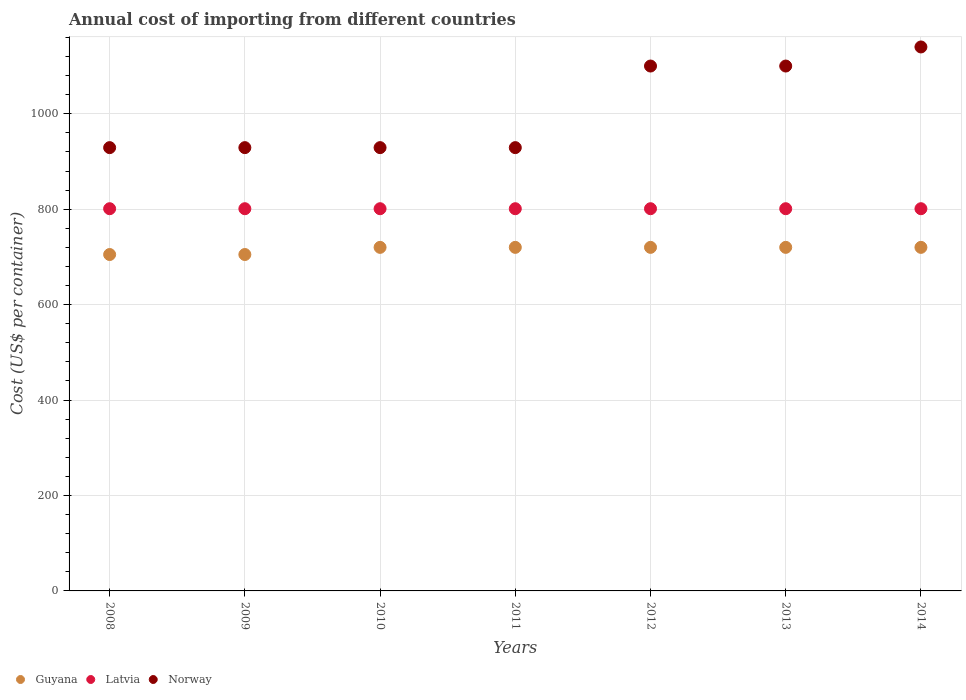Is the number of dotlines equal to the number of legend labels?
Your answer should be very brief. Yes. What is the total annual cost of importing in Norway in 2014?
Give a very brief answer. 1140. Across all years, what is the maximum total annual cost of importing in Norway?
Provide a succinct answer. 1140. Across all years, what is the minimum total annual cost of importing in Latvia?
Give a very brief answer. 801. In which year was the total annual cost of importing in Latvia maximum?
Provide a short and direct response. 2008. In which year was the total annual cost of importing in Latvia minimum?
Your answer should be very brief. 2008. What is the total total annual cost of importing in Latvia in the graph?
Provide a succinct answer. 5607. What is the difference between the total annual cost of importing in Latvia in 2012 and the total annual cost of importing in Norway in 2009?
Keep it short and to the point. -128. What is the average total annual cost of importing in Norway per year?
Provide a succinct answer. 1008. In the year 2011, what is the difference between the total annual cost of importing in Latvia and total annual cost of importing in Norway?
Your answer should be very brief. -128. In how many years, is the total annual cost of importing in Guyana greater than 880 US$?
Provide a short and direct response. 0. What is the ratio of the total annual cost of importing in Latvia in 2008 to that in 2009?
Offer a very short reply. 1. Is the total annual cost of importing in Norway in 2009 less than that in 2012?
Make the answer very short. Yes. Is the difference between the total annual cost of importing in Latvia in 2010 and 2013 greater than the difference between the total annual cost of importing in Norway in 2010 and 2013?
Provide a short and direct response. Yes. What is the difference between the highest and the second highest total annual cost of importing in Norway?
Make the answer very short. 40. What is the difference between the highest and the lowest total annual cost of importing in Norway?
Keep it short and to the point. 211. Is it the case that in every year, the sum of the total annual cost of importing in Guyana and total annual cost of importing in Norway  is greater than the total annual cost of importing in Latvia?
Make the answer very short. Yes. Is the total annual cost of importing in Latvia strictly greater than the total annual cost of importing in Norway over the years?
Offer a very short reply. No. Is the total annual cost of importing in Latvia strictly less than the total annual cost of importing in Guyana over the years?
Your answer should be very brief. No. How many dotlines are there?
Give a very brief answer. 3. How many years are there in the graph?
Your response must be concise. 7. Does the graph contain grids?
Ensure brevity in your answer.  Yes. How are the legend labels stacked?
Provide a succinct answer. Horizontal. What is the title of the graph?
Offer a very short reply. Annual cost of importing from different countries. What is the label or title of the X-axis?
Provide a succinct answer. Years. What is the label or title of the Y-axis?
Offer a terse response. Cost (US$ per container). What is the Cost (US$ per container) of Guyana in 2008?
Your answer should be compact. 705. What is the Cost (US$ per container) of Latvia in 2008?
Give a very brief answer. 801. What is the Cost (US$ per container) of Norway in 2008?
Offer a terse response. 929. What is the Cost (US$ per container) of Guyana in 2009?
Keep it short and to the point. 705. What is the Cost (US$ per container) of Latvia in 2009?
Offer a terse response. 801. What is the Cost (US$ per container) of Norway in 2009?
Make the answer very short. 929. What is the Cost (US$ per container) of Guyana in 2010?
Ensure brevity in your answer.  720. What is the Cost (US$ per container) of Latvia in 2010?
Provide a short and direct response. 801. What is the Cost (US$ per container) in Norway in 2010?
Your answer should be very brief. 929. What is the Cost (US$ per container) of Guyana in 2011?
Ensure brevity in your answer.  720. What is the Cost (US$ per container) of Latvia in 2011?
Your answer should be very brief. 801. What is the Cost (US$ per container) of Norway in 2011?
Your response must be concise. 929. What is the Cost (US$ per container) of Guyana in 2012?
Make the answer very short. 720. What is the Cost (US$ per container) of Latvia in 2012?
Your answer should be very brief. 801. What is the Cost (US$ per container) in Norway in 2012?
Ensure brevity in your answer.  1100. What is the Cost (US$ per container) in Guyana in 2013?
Provide a succinct answer. 720. What is the Cost (US$ per container) of Latvia in 2013?
Make the answer very short. 801. What is the Cost (US$ per container) of Norway in 2013?
Make the answer very short. 1100. What is the Cost (US$ per container) in Guyana in 2014?
Provide a short and direct response. 720. What is the Cost (US$ per container) of Latvia in 2014?
Keep it short and to the point. 801. What is the Cost (US$ per container) of Norway in 2014?
Ensure brevity in your answer.  1140. Across all years, what is the maximum Cost (US$ per container) of Guyana?
Ensure brevity in your answer.  720. Across all years, what is the maximum Cost (US$ per container) in Latvia?
Keep it short and to the point. 801. Across all years, what is the maximum Cost (US$ per container) in Norway?
Your answer should be very brief. 1140. Across all years, what is the minimum Cost (US$ per container) of Guyana?
Provide a short and direct response. 705. Across all years, what is the minimum Cost (US$ per container) of Latvia?
Provide a succinct answer. 801. Across all years, what is the minimum Cost (US$ per container) in Norway?
Offer a terse response. 929. What is the total Cost (US$ per container) in Guyana in the graph?
Provide a short and direct response. 5010. What is the total Cost (US$ per container) in Latvia in the graph?
Ensure brevity in your answer.  5607. What is the total Cost (US$ per container) in Norway in the graph?
Provide a succinct answer. 7056. What is the difference between the Cost (US$ per container) in Norway in 2008 and that in 2009?
Your answer should be compact. 0. What is the difference between the Cost (US$ per container) of Norway in 2008 and that in 2010?
Your answer should be compact. 0. What is the difference between the Cost (US$ per container) of Guyana in 2008 and that in 2011?
Make the answer very short. -15. What is the difference between the Cost (US$ per container) in Norway in 2008 and that in 2011?
Your response must be concise. 0. What is the difference between the Cost (US$ per container) in Norway in 2008 and that in 2012?
Provide a short and direct response. -171. What is the difference between the Cost (US$ per container) of Norway in 2008 and that in 2013?
Your response must be concise. -171. What is the difference between the Cost (US$ per container) of Latvia in 2008 and that in 2014?
Provide a short and direct response. 0. What is the difference between the Cost (US$ per container) of Norway in 2008 and that in 2014?
Your response must be concise. -211. What is the difference between the Cost (US$ per container) of Guyana in 2009 and that in 2010?
Offer a very short reply. -15. What is the difference between the Cost (US$ per container) in Latvia in 2009 and that in 2010?
Provide a short and direct response. 0. What is the difference between the Cost (US$ per container) of Latvia in 2009 and that in 2011?
Keep it short and to the point. 0. What is the difference between the Cost (US$ per container) in Norway in 2009 and that in 2011?
Make the answer very short. 0. What is the difference between the Cost (US$ per container) of Guyana in 2009 and that in 2012?
Keep it short and to the point. -15. What is the difference between the Cost (US$ per container) of Norway in 2009 and that in 2012?
Your response must be concise. -171. What is the difference between the Cost (US$ per container) in Latvia in 2009 and that in 2013?
Offer a terse response. 0. What is the difference between the Cost (US$ per container) of Norway in 2009 and that in 2013?
Your answer should be very brief. -171. What is the difference between the Cost (US$ per container) of Guyana in 2009 and that in 2014?
Provide a succinct answer. -15. What is the difference between the Cost (US$ per container) of Norway in 2009 and that in 2014?
Offer a very short reply. -211. What is the difference between the Cost (US$ per container) of Guyana in 2010 and that in 2012?
Give a very brief answer. 0. What is the difference between the Cost (US$ per container) in Norway in 2010 and that in 2012?
Offer a very short reply. -171. What is the difference between the Cost (US$ per container) in Guyana in 2010 and that in 2013?
Keep it short and to the point. 0. What is the difference between the Cost (US$ per container) in Latvia in 2010 and that in 2013?
Keep it short and to the point. 0. What is the difference between the Cost (US$ per container) in Norway in 2010 and that in 2013?
Offer a very short reply. -171. What is the difference between the Cost (US$ per container) of Guyana in 2010 and that in 2014?
Make the answer very short. 0. What is the difference between the Cost (US$ per container) of Norway in 2010 and that in 2014?
Your response must be concise. -211. What is the difference between the Cost (US$ per container) in Guyana in 2011 and that in 2012?
Keep it short and to the point. 0. What is the difference between the Cost (US$ per container) in Latvia in 2011 and that in 2012?
Offer a very short reply. 0. What is the difference between the Cost (US$ per container) in Norway in 2011 and that in 2012?
Provide a succinct answer. -171. What is the difference between the Cost (US$ per container) of Guyana in 2011 and that in 2013?
Provide a short and direct response. 0. What is the difference between the Cost (US$ per container) in Latvia in 2011 and that in 2013?
Provide a succinct answer. 0. What is the difference between the Cost (US$ per container) in Norway in 2011 and that in 2013?
Offer a very short reply. -171. What is the difference between the Cost (US$ per container) of Guyana in 2011 and that in 2014?
Provide a succinct answer. 0. What is the difference between the Cost (US$ per container) of Norway in 2011 and that in 2014?
Provide a short and direct response. -211. What is the difference between the Cost (US$ per container) of Latvia in 2012 and that in 2013?
Ensure brevity in your answer.  0. What is the difference between the Cost (US$ per container) in Guyana in 2013 and that in 2014?
Ensure brevity in your answer.  0. What is the difference between the Cost (US$ per container) of Norway in 2013 and that in 2014?
Provide a short and direct response. -40. What is the difference between the Cost (US$ per container) in Guyana in 2008 and the Cost (US$ per container) in Latvia in 2009?
Your response must be concise. -96. What is the difference between the Cost (US$ per container) of Guyana in 2008 and the Cost (US$ per container) of Norway in 2009?
Keep it short and to the point. -224. What is the difference between the Cost (US$ per container) of Latvia in 2008 and the Cost (US$ per container) of Norway in 2009?
Provide a succinct answer. -128. What is the difference between the Cost (US$ per container) of Guyana in 2008 and the Cost (US$ per container) of Latvia in 2010?
Your answer should be very brief. -96. What is the difference between the Cost (US$ per container) in Guyana in 2008 and the Cost (US$ per container) in Norway in 2010?
Your response must be concise. -224. What is the difference between the Cost (US$ per container) of Latvia in 2008 and the Cost (US$ per container) of Norway in 2010?
Ensure brevity in your answer.  -128. What is the difference between the Cost (US$ per container) of Guyana in 2008 and the Cost (US$ per container) of Latvia in 2011?
Offer a very short reply. -96. What is the difference between the Cost (US$ per container) of Guyana in 2008 and the Cost (US$ per container) of Norway in 2011?
Give a very brief answer. -224. What is the difference between the Cost (US$ per container) of Latvia in 2008 and the Cost (US$ per container) of Norway in 2011?
Your answer should be compact. -128. What is the difference between the Cost (US$ per container) in Guyana in 2008 and the Cost (US$ per container) in Latvia in 2012?
Offer a very short reply. -96. What is the difference between the Cost (US$ per container) of Guyana in 2008 and the Cost (US$ per container) of Norway in 2012?
Your answer should be very brief. -395. What is the difference between the Cost (US$ per container) of Latvia in 2008 and the Cost (US$ per container) of Norway in 2012?
Offer a terse response. -299. What is the difference between the Cost (US$ per container) in Guyana in 2008 and the Cost (US$ per container) in Latvia in 2013?
Give a very brief answer. -96. What is the difference between the Cost (US$ per container) in Guyana in 2008 and the Cost (US$ per container) in Norway in 2013?
Ensure brevity in your answer.  -395. What is the difference between the Cost (US$ per container) in Latvia in 2008 and the Cost (US$ per container) in Norway in 2013?
Keep it short and to the point. -299. What is the difference between the Cost (US$ per container) of Guyana in 2008 and the Cost (US$ per container) of Latvia in 2014?
Give a very brief answer. -96. What is the difference between the Cost (US$ per container) in Guyana in 2008 and the Cost (US$ per container) in Norway in 2014?
Give a very brief answer. -435. What is the difference between the Cost (US$ per container) of Latvia in 2008 and the Cost (US$ per container) of Norway in 2014?
Make the answer very short. -339. What is the difference between the Cost (US$ per container) of Guyana in 2009 and the Cost (US$ per container) of Latvia in 2010?
Give a very brief answer. -96. What is the difference between the Cost (US$ per container) of Guyana in 2009 and the Cost (US$ per container) of Norway in 2010?
Your response must be concise. -224. What is the difference between the Cost (US$ per container) in Latvia in 2009 and the Cost (US$ per container) in Norway in 2010?
Offer a very short reply. -128. What is the difference between the Cost (US$ per container) in Guyana in 2009 and the Cost (US$ per container) in Latvia in 2011?
Provide a short and direct response. -96. What is the difference between the Cost (US$ per container) in Guyana in 2009 and the Cost (US$ per container) in Norway in 2011?
Keep it short and to the point. -224. What is the difference between the Cost (US$ per container) of Latvia in 2009 and the Cost (US$ per container) of Norway in 2011?
Make the answer very short. -128. What is the difference between the Cost (US$ per container) of Guyana in 2009 and the Cost (US$ per container) of Latvia in 2012?
Make the answer very short. -96. What is the difference between the Cost (US$ per container) of Guyana in 2009 and the Cost (US$ per container) of Norway in 2012?
Your response must be concise. -395. What is the difference between the Cost (US$ per container) of Latvia in 2009 and the Cost (US$ per container) of Norway in 2012?
Provide a succinct answer. -299. What is the difference between the Cost (US$ per container) of Guyana in 2009 and the Cost (US$ per container) of Latvia in 2013?
Your response must be concise. -96. What is the difference between the Cost (US$ per container) in Guyana in 2009 and the Cost (US$ per container) in Norway in 2013?
Give a very brief answer. -395. What is the difference between the Cost (US$ per container) in Latvia in 2009 and the Cost (US$ per container) in Norway in 2013?
Your response must be concise. -299. What is the difference between the Cost (US$ per container) of Guyana in 2009 and the Cost (US$ per container) of Latvia in 2014?
Ensure brevity in your answer.  -96. What is the difference between the Cost (US$ per container) of Guyana in 2009 and the Cost (US$ per container) of Norway in 2014?
Your response must be concise. -435. What is the difference between the Cost (US$ per container) of Latvia in 2009 and the Cost (US$ per container) of Norway in 2014?
Provide a short and direct response. -339. What is the difference between the Cost (US$ per container) in Guyana in 2010 and the Cost (US$ per container) in Latvia in 2011?
Your answer should be compact. -81. What is the difference between the Cost (US$ per container) of Guyana in 2010 and the Cost (US$ per container) of Norway in 2011?
Offer a very short reply. -209. What is the difference between the Cost (US$ per container) in Latvia in 2010 and the Cost (US$ per container) in Norway in 2011?
Keep it short and to the point. -128. What is the difference between the Cost (US$ per container) of Guyana in 2010 and the Cost (US$ per container) of Latvia in 2012?
Your answer should be compact. -81. What is the difference between the Cost (US$ per container) of Guyana in 2010 and the Cost (US$ per container) of Norway in 2012?
Provide a succinct answer. -380. What is the difference between the Cost (US$ per container) of Latvia in 2010 and the Cost (US$ per container) of Norway in 2012?
Keep it short and to the point. -299. What is the difference between the Cost (US$ per container) in Guyana in 2010 and the Cost (US$ per container) in Latvia in 2013?
Ensure brevity in your answer.  -81. What is the difference between the Cost (US$ per container) in Guyana in 2010 and the Cost (US$ per container) in Norway in 2013?
Provide a succinct answer. -380. What is the difference between the Cost (US$ per container) in Latvia in 2010 and the Cost (US$ per container) in Norway in 2013?
Offer a terse response. -299. What is the difference between the Cost (US$ per container) in Guyana in 2010 and the Cost (US$ per container) in Latvia in 2014?
Offer a terse response. -81. What is the difference between the Cost (US$ per container) of Guyana in 2010 and the Cost (US$ per container) of Norway in 2014?
Offer a terse response. -420. What is the difference between the Cost (US$ per container) in Latvia in 2010 and the Cost (US$ per container) in Norway in 2014?
Offer a terse response. -339. What is the difference between the Cost (US$ per container) of Guyana in 2011 and the Cost (US$ per container) of Latvia in 2012?
Ensure brevity in your answer.  -81. What is the difference between the Cost (US$ per container) of Guyana in 2011 and the Cost (US$ per container) of Norway in 2012?
Give a very brief answer. -380. What is the difference between the Cost (US$ per container) in Latvia in 2011 and the Cost (US$ per container) in Norway in 2012?
Your response must be concise. -299. What is the difference between the Cost (US$ per container) of Guyana in 2011 and the Cost (US$ per container) of Latvia in 2013?
Ensure brevity in your answer.  -81. What is the difference between the Cost (US$ per container) of Guyana in 2011 and the Cost (US$ per container) of Norway in 2013?
Your response must be concise. -380. What is the difference between the Cost (US$ per container) in Latvia in 2011 and the Cost (US$ per container) in Norway in 2013?
Ensure brevity in your answer.  -299. What is the difference between the Cost (US$ per container) in Guyana in 2011 and the Cost (US$ per container) in Latvia in 2014?
Offer a very short reply. -81. What is the difference between the Cost (US$ per container) of Guyana in 2011 and the Cost (US$ per container) of Norway in 2014?
Provide a short and direct response. -420. What is the difference between the Cost (US$ per container) of Latvia in 2011 and the Cost (US$ per container) of Norway in 2014?
Provide a short and direct response. -339. What is the difference between the Cost (US$ per container) in Guyana in 2012 and the Cost (US$ per container) in Latvia in 2013?
Give a very brief answer. -81. What is the difference between the Cost (US$ per container) of Guyana in 2012 and the Cost (US$ per container) of Norway in 2013?
Offer a terse response. -380. What is the difference between the Cost (US$ per container) in Latvia in 2012 and the Cost (US$ per container) in Norway in 2013?
Provide a short and direct response. -299. What is the difference between the Cost (US$ per container) of Guyana in 2012 and the Cost (US$ per container) of Latvia in 2014?
Your answer should be compact. -81. What is the difference between the Cost (US$ per container) in Guyana in 2012 and the Cost (US$ per container) in Norway in 2014?
Ensure brevity in your answer.  -420. What is the difference between the Cost (US$ per container) in Latvia in 2012 and the Cost (US$ per container) in Norway in 2014?
Your answer should be compact. -339. What is the difference between the Cost (US$ per container) in Guyana in 2013 and the Cost (US$ per container) in Latvia in 2014?
Your response must be concise. -81. What is the difference between the Cost (US$ per container) in Guyana in 2013 and the Cost (US$ per container) in Norway in 2014?
Your answer should be very brief. -420. What is the difference between the Cost (US$ per container) in Latvia in 2013 and the Cost (US$ per container) in Norway in 2014?
Your answer should be very brief. -339. What is the average Cost (US$ per container) in Guyana per year?
Make the answer very short. 715.71. What is the average Cost (US$ per container) of Latvia per year?
Keep it short and to the point. 801. What is the average Cost (US$ per container) of Norway per year?
Offer a terse response. 1008. In the year 2008, what is the difference between the Cost (US$ per container) of Guyana and Cost (US$ per container) of Latvia?
Your answer should be very brief. -96. In the year 2008, what is the difference between the Cost (US$ per container) in Guyana and Cost (US$ per container) in Norway?
Ensure brevity in your answer.  -224. In the year 2008, what is the difference between the Cost (US$ per container) in Latvia and Cost (US$ per container) in Norway?
Keep it short and to the point. -128. In the year 2009, what is the difference between the Cost (US$ per container) in Guyana and Cost (US$ per container) in Latvia?
Your response must be concise. -96. In the year 2009, what is the difference between the Cost (US$ per container) of Guyana and Cost (US$ per container) of Norway?
Your answer should be very brief. -224. In the year 2009, what is the difference between the Cost (US$ per container) in Latvia and Cost (US$ per container) in Norway?
Your answer should be compact. -128. In the year 2010, what is the difference between the Cost (US$ per container) in Guyana and Cost (US$ per container) in Latvia?
Provide a short and direct response. -81. In the year 2010, what is the difference between the Cost (US$ per container) in Guyana and Cost (US$ per container) in Norway?
Offer a very short reply. -209. In the year 2010, what is the difference between the Cost (US$ per container) of Latvia and Cost (US$ per container) of Norway?
Give a very brief answer. -128. In the year 2011, what is the difference between the Cost (US$ per container) in Guyana and Cost (US$ per container) in Latvia?
Your answer should be very brief. -81. In the year 2011, what is the difference between the Cost (US$ per container) in Guyana and Cost (US$ per container) in Norway?
Your answer should be very brief. -209. In the year 2011, what is the difference between the Cost (US$ per container) of Latvia and Cost (US$ per container) of Norway?
Your answer should be very brief. -128. In the year 2012, what is the difference between the Cost (US$ per container) of Guyana and Cost (US$ per container) of Latvia?
Offer a very short reply. -81. In the year 2012, what is the difference between the Cost (US$ per container) of Guyana and Cost (US$ per container) of Norway?
Your answer should be very brief. -380. In the year 2012, what is the difference between the Cost (US$ per container) in Latvia and Cost (US$ per container) in Norway?
Ensure brevity in your answer.  -299. In the year 2013, what is the difference between the Cost (US$ per container) in Guyana and Cost (US$ per container) in Latvia?
Your answer should be very brief. -81. In the year 2013, what is the difference between the Cost (US$ per container) in Guyana and Cost (US$ per container) in Norway?
Provide a short and direct response. -380. In the year 2013, what is the difference between the Cost (US$ per container) of Latvia and Cost (US$ per container) of Norway?
Give a very brief answer. -299. In the year 2014, what is the difference between the Cost (US$ per container) in Guyana and Cost (US$ per container) in Latvia?
Provide a short and direct response. -81. In the year 2014, what is the difference between the Cost (US$ per container) of Guyana and Cost (US$ per container) of Norway?
Your answer should be very brief. -420. In the year 2014, what is the difference between the Cost (US$ per container) in Latvia and Cost (US$ per container) in Norway?
Provide a short and direct response. -339. What is the ratio of the Cost (US$ per container) of Guyana in 2008 to that in 2009?
Provide a succinct answer. 1. What is the ratio of the Cost (US$ per container) of Latvia in 2008 to that in 2009?
Your response must be concise. 1. What is the ratio of the Cost (US$ per container) of Norway in 2008 to that in 2009?
Provide a short and direct response. 1. What is the ratio of the Cost (US$ per container) of Guyana in 2008 to that in 2010?
Your answer should be compact. 0.98. What is the ratio of the Cost (US$ per container) of Latvia in 2008 to that in 2010?
Your response must be concise. 1. What is the ratio of the Cost (US$ per container) in Guyana in 2008 to that in 2011?
Make the answer very short. 0.98. What is the ratio of the Cost (US$ per container) of Latvia in 2008 to that in 2011?
Ensure brevity in your answer.  1. What is the ratio of the Cost (US$ per container) of Norway in 2008 to that in 2011?
Provide a short and direct response. 1. What is the ratio of the Cost (US$ per container) of Guyana in 2008 to that in 2012?
Give a very brief answer. 0.98. What is the ratio of the Cost (US$ per container) of Norway in 2008 to that in 2012?
Your answer should be very brief. 0.84. What is the ratio of the Cost (US$ per container) of Guyana in 2008 to that in 2013?
Ensure brevity in your answer.  0.98. What is the ratio of the Cost (US$ per container) of Latvia in 2008 to that in 2013?
Your response must be concise. 1. What is the ratio of the Cost (US$ per container) in Norway in 2008 to that in 2013?
Offer a terse response. 0.84. What is the ratio of the Cost (US$ per container) in Guyana in 2008 to that in 2014?
Offer a very short reply. 0.98. What is the ratio of the Cost (US$ per container) of Latvia in 2008 to that in 2014?
Offer a very short reply. 1. What is the ratio of the Cost (US$ per container) in Norway in 2008 to that in 2014?
Keep it short and to the point. 0.81. What is the ratio of the Cost (US$ per container) in Guyana in 2009 to that in 2010?
Ensure brevity in your answer.  0.98. What is the ratio of the Cost (US$ per container) of Guyana in 2009 to that in 2011?
Your answer should be very brief. 0.98. What is the ratio of the Cost (US$ per container) of Norway in 2009 to that in 2011?
Provide a short and direct response. 1. What is the ratio of the Cost (US$ per container) of Guyana in 2009 to that in 2012?
Provide a succinct answer. 0.98. What is the ratio of the Cost (US$ per container) of Norway in 2009 to that in 2012?
Give a very brief answer. 0.84. What is the ratio of the Cost (US$ per container) in Guyana in 2009 to that in 2013?
Give a very brief answer. 0.98. What is the ratio of the Cost (US$ per container) of Latvia in 2009 to that in 2013?
Ensure brevity in your answer.  1. What is the ratio of the Cost (US$ per container) in Norway in 2009 to that in 2013?
Provide a short and direct response. 0.84. What is the ratio of the Cost (US$ per container) of Guyana in 2009 to that in 2014?
Give a very brief answer. 0.98. What is the ratio of the Cost (US$ per container) in Latvia in 2009 to that in 2014?
Offer a very short reply. 1. What is the ratio of the Cost (US$ per container) in Norway in 2009 to that in 2014?
Your response must be concise. 0.81. What is the ratio of the Cost (US$ per container) of Guyana in 2010 to that in 2011?
Provide a succinct answer. 1. What is the ratio of the Cost (US$ per container) in Norway in 2010 to that in 2011?
Offer a very short reply. 1. What is the ratio of the Cost (US$ per container) of Norway in 2010 to that in 2012?
Keep it short and to the point. 0.84. What is the ratio of the Cost (US$ per container) in Guyana in 2010 to that in 2013?
Offer a very short reply. 1. What is the ratio of the Cost (US$ per container) in Norway in 2010 to that in 2013?
Provide a succinct answer. 0.84. What is the ratio of the Cost (US$ per container) in Guyana in 2010 to that in 2014?
Ensure brevity in your answer.  1. What is the ratio of the Cost (US$ per container) in Norway in 2010 to that in 2014?
Give a very brief answer. 0.81. What is the ratio of the Cost (US$ per container) in Guyana in 2011 to that in 2012?
Offer a terse response. 1. What is the ratio of the Cost (US$ per container) in Norway in 2011 to that in 2012?
Provide a short and direct response. 0.84. What is the ratio of the Cost (US$ per container) in Norway in 2011 to that in 2013?
Offer a terse response. 0.84. What is the ratio of the Cost (US$ per container) in Norway in 2011 to that in 2014?
Give a very brief answer. 0.81. What is the ratio of the Cost (US$ per container) of Norway in 2012 to that in 2013?
Keep it short and to the point. 1. What is the ratio of the Cost (US$ per container) in Guyana in 2012 to that in 2014?
Offer a very short reply. 1. What is the ratio of the Cost (US$ per container) in Latvia in 2012 to that in 2014?
Make the answer very short. 1. What is the ratio of the Cost (US$ per container) in Norway in 2012 to that in 2014?
Ensure brevity in your answer.  0.96. What is the ratio of the Cost (US$ per container) in Guyana in 2013 to that in 2014?
Your answer should be compact. 1. What is the ratio of the Cost (US$ per container) in Norway in 2013 to that in 2014?
Keep it short and to the point. 0.96. What is the difference between the highest and the second highest Cost (US$ per container) of Guyana?
Your answer should be very brief. 0. What is the difference between the highest and the second highest Cost (US$ per container) in Latvia?
Your answer should be compact. 0. What is the difference between the highest and the second highest Cost (US$ per container) in Norway?
Your answer should be compact. 40. What is the difference between the highest and the lowest Cost (US$ per container) of Guyana?
Keep it short and to the point. 15. What is the difference between the highest and the lowest Cost (US$ per container) in Latvia?
Your response must be concise. 0. What is the difference between the highest and the lowest Cost (US$ per container) of Norway?
Ensure brevity in your answer.  211. 